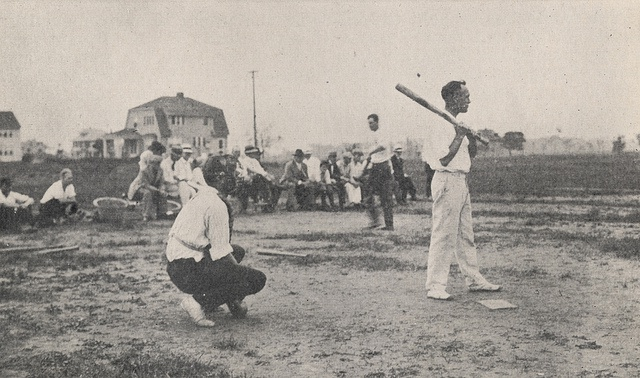Describe the objects in this image and their specific colors. I can see people in lightgray, gray, and darkgray tones, people in lightgray, darkgray, and gray tones, people in lightgray, gray, and darkgray tones, people in lightgray, gray, and darkgray tones, and people in lightgray, gray, and darkgray tones in this image. 